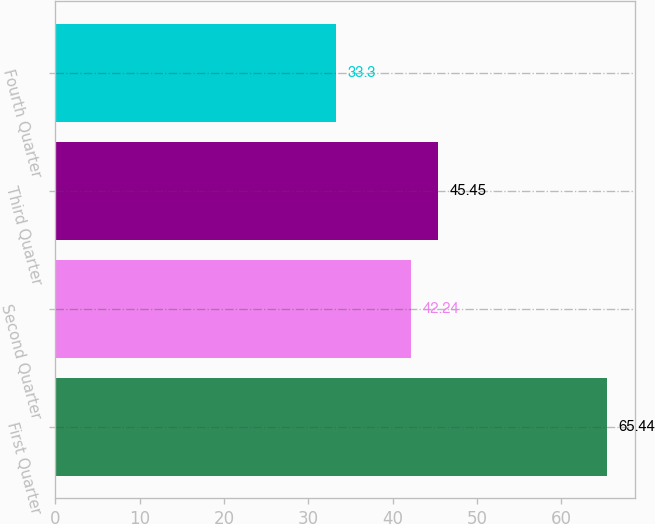Convert chart. <chart><loc_0><loc_0><loc_500><loc_500><bar_chart><fcel>First Quarter<fcel>Second Quarter<fcel>Third Quarter<fcel>Fourth Quarter<nl><fcel>65.44<fcel>42.24<fcel>45.45<fcel>33.3<nl></chart> 